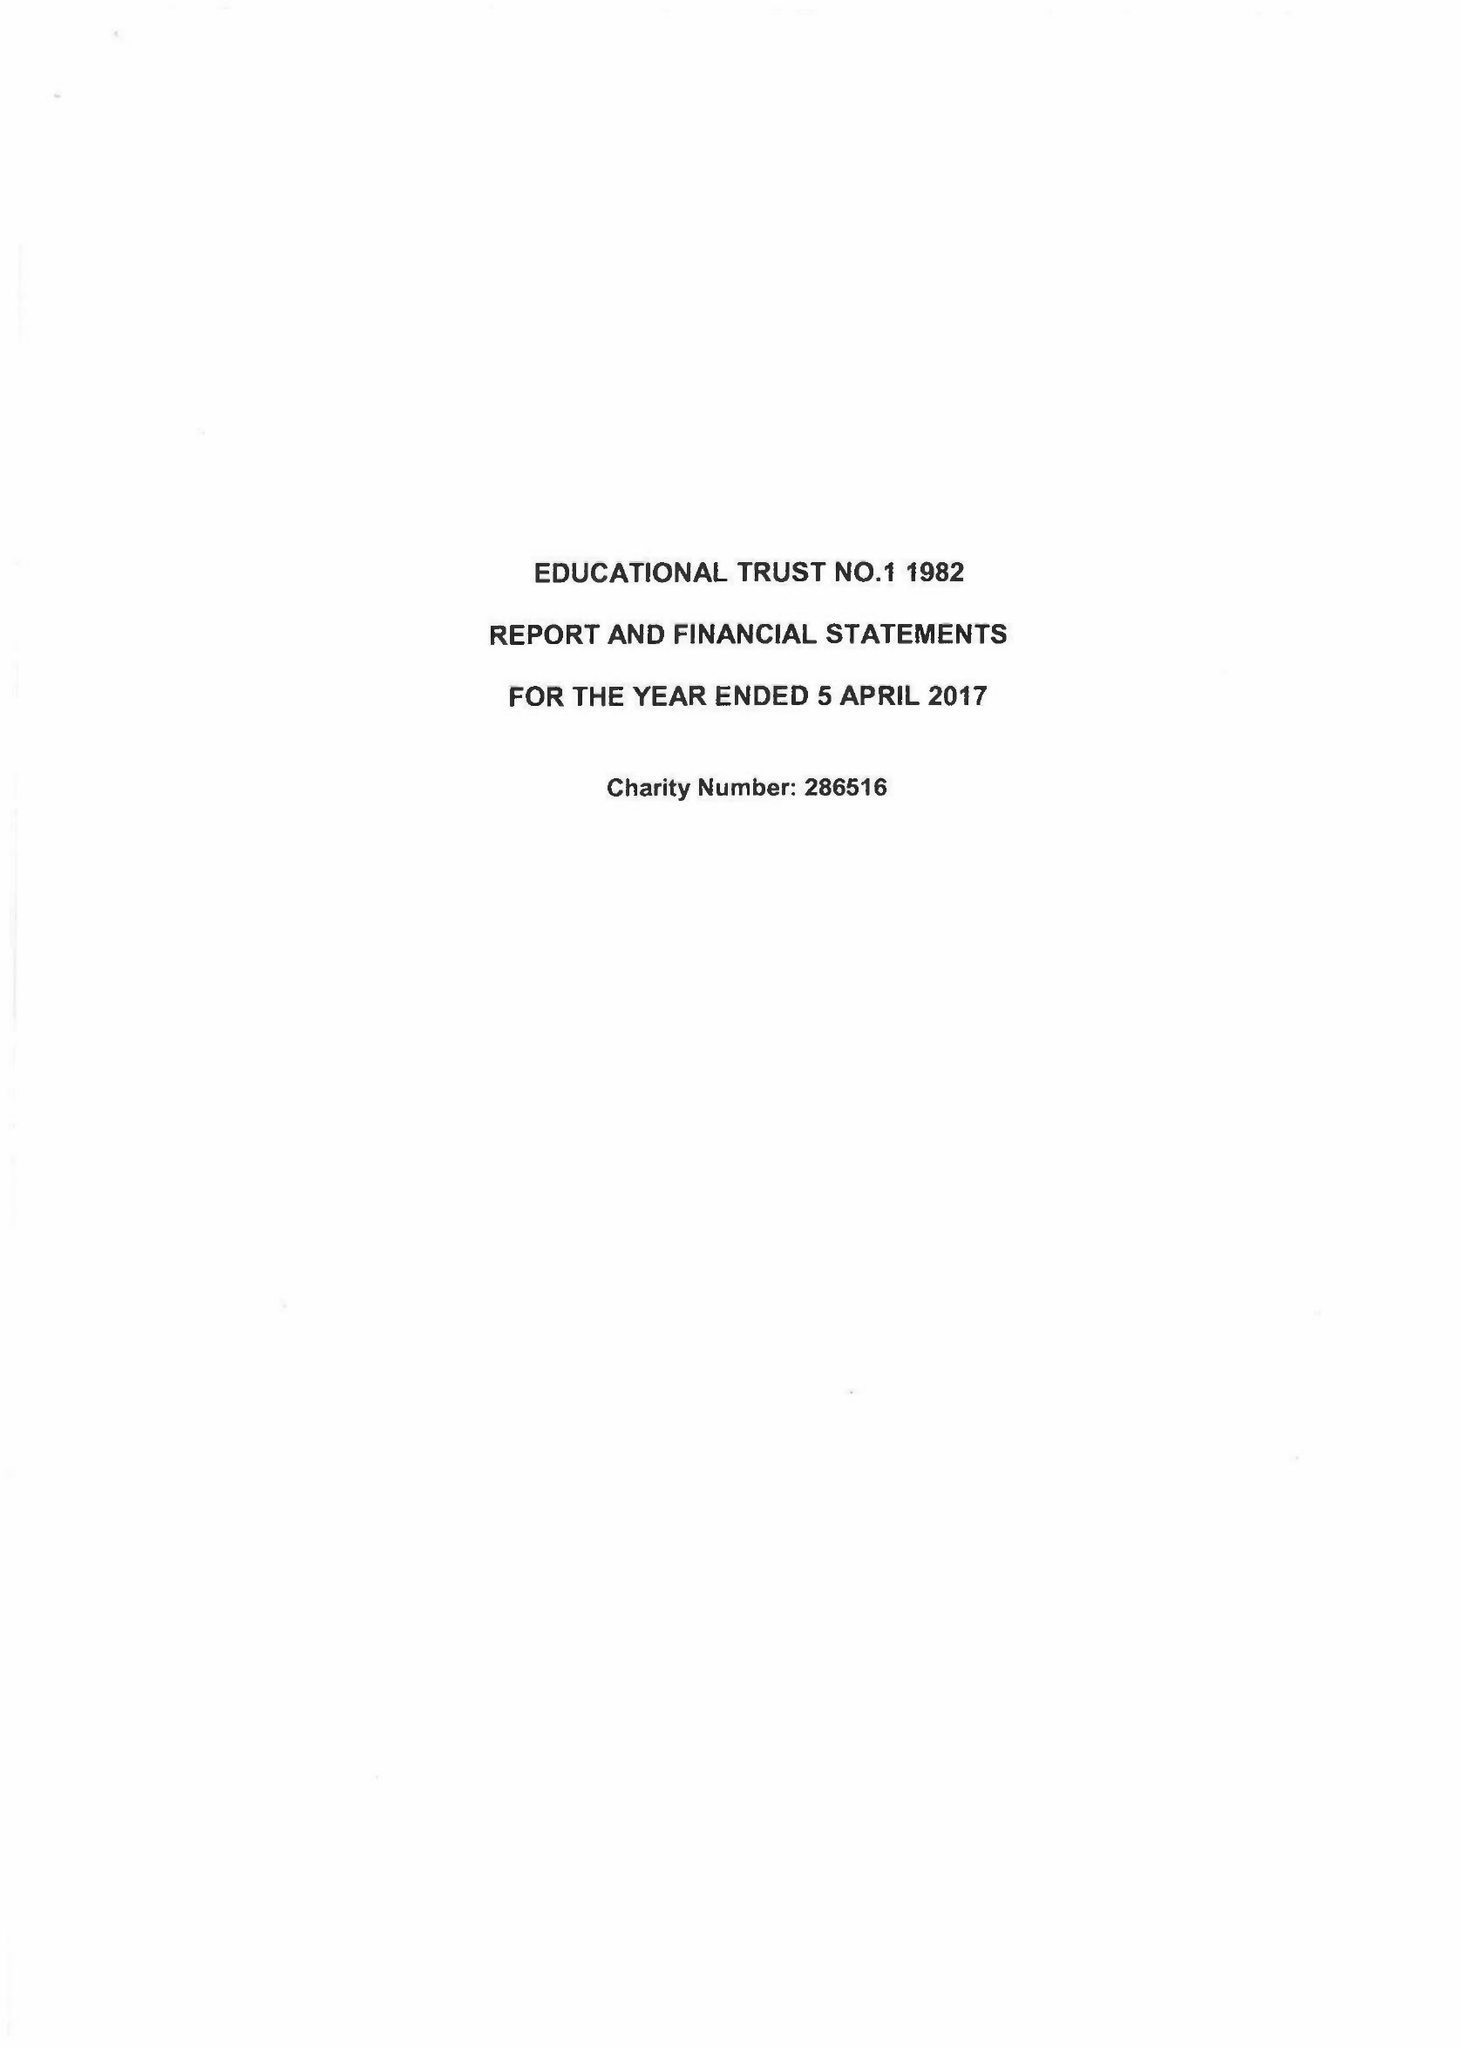What is the value for the report_date?
Answer the question using a single word or phrase. 2017-04-05 